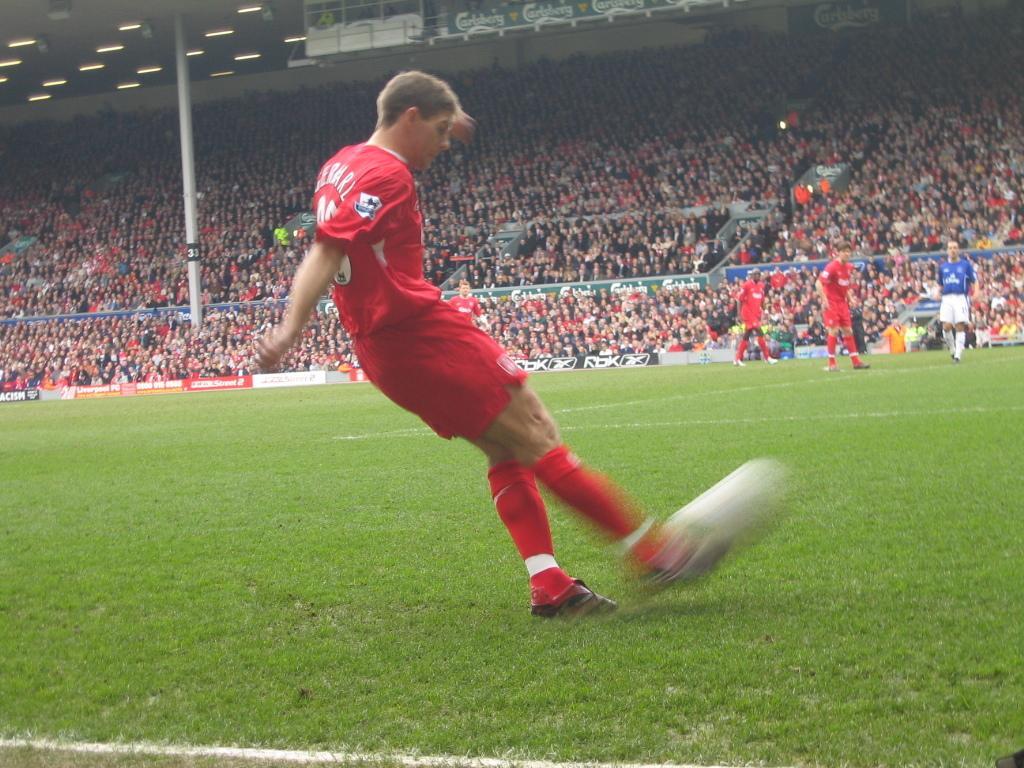How would you summarize this image in a sentence or two? In this image there is a man standing on the ground. Near his legs there is an object. It is blurry. It seems to be a ball. To the right there are three people standing on the ground. In the background there are many people sitting on the chairs. In the top left there are lights to the ceiling. Beside it there are boards. 